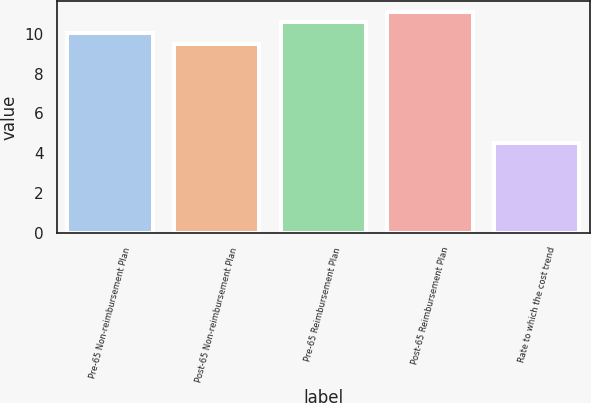Convert chart to OTSL. <chart><loc_0><loc_0><loc_500><loc_500><bar_chart><fcel>Pre-65 Non-reimbursement Plan<fcel>Post-65 Non-reimbursement Plan<fcel>Pre-65 Reimbursement Plan<fcel>Post-65 Reimbursement Plan<fcel>Rate to which the cost trend<nl><fcel>10.03<fcel>9.5<fcel>10.56<fcel>11.09<fcel>4.5<nl></chart> 